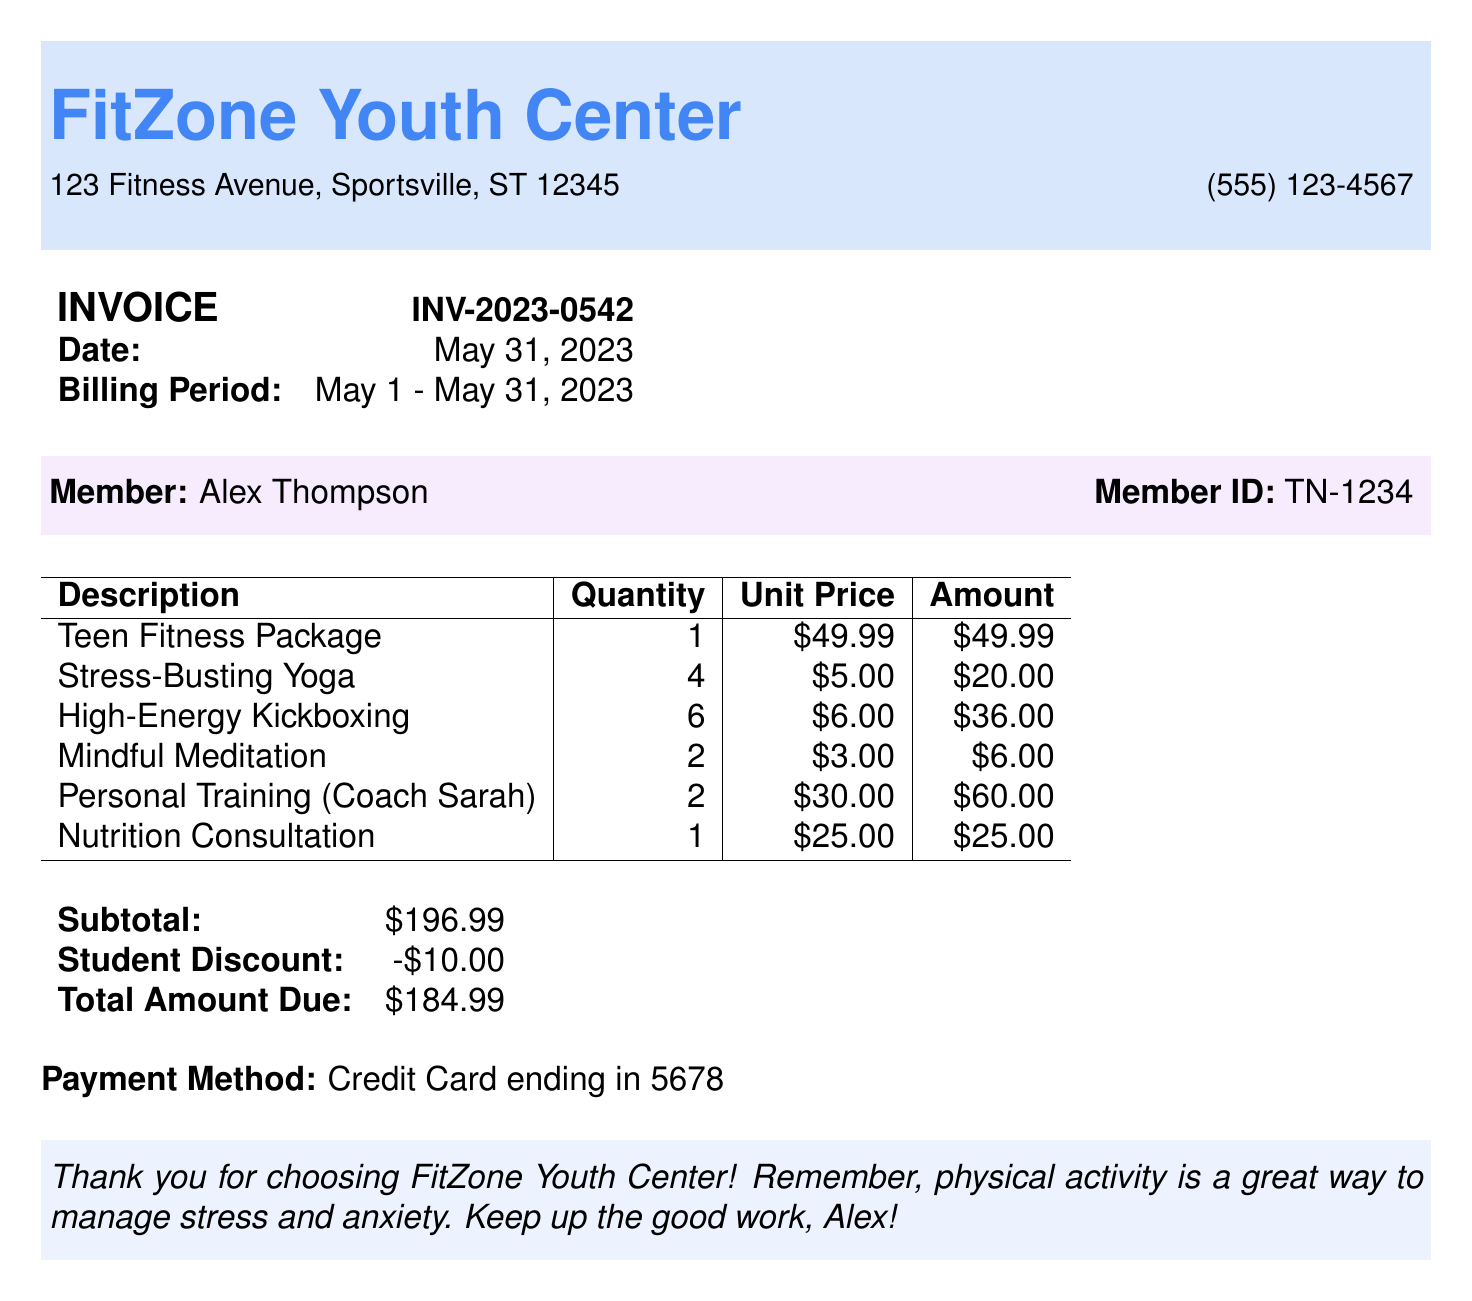What is the invoice number? The invoice number is a unique identifier for the billing document, which is found in the header section.
Answer: INV-2023-0542 Who is the member? The member's name, provided for billing purposes, is listed prominently in the document.
Answer: Alex Thompson What is the total amount due? The total amount due is the final figure that includes all charges minus any discounts, located near the bottom.
Answer: $184.99 How many classes did Alex attend for High-Energy Kickboxing? This number can be found in the classes attended section, detailing the counts for each class.
Answer: 6 What is the price per session for personal training? The price per session for personal training is stated in the personal training section of the document.
Answer: $30.00 How much was the student discount? The discount amount is noted in the summary section, providing a reduction on the subtotal.
Answer: $10.00 What is the billing period covered by this invoice? The billing period shows the range of dates for which the services were rendered, located in the header section.
Answer: May 1 - May 31, 2023 What additional service was included apart from fitness classes? This service is listed under additional services in the invoice along with its price and quantity.
Answer: Nutrition Consultation How many sessions of Mindful Meditation did Alex attend? This information can be found within the classes attended section, which details the number of sessions for each class type.
Answer: 2 